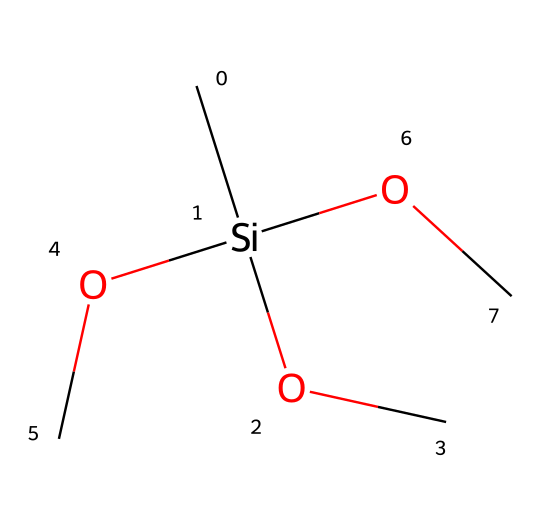What is the molecular formula of methyltrimethoxysilane? The chemical structure shows one silicon atom (Si), one carbon atom (C) from the methyl group, and three methoxy groups (-OCH3), which combine to give the molecular formula SiC4H12O3.
Answer: SiC4H12O3 How many methoxy groups are present in methyltrimethoxysilane? The chemical structure includes three -OCH3 groups attached to the silicon atom. Each methoxy group contributes to one part of the molecular structure, which is evident from the three –O and three –C in the SMILES, indicating three methoxy groups.
Answer: 3 What type of functional groups are present in this chemical? The structure reveals that there are methoxy groups (-OCH3) and a silane group (Si-R), where R represents the organic components. The presence of both methoxy and silane groups characterizes it as a silane with methoxy functionalities.
Answer: methoxy and silane groups Which atom in the structure is responsible for the silane properties? The central silicon atom (Si) is surrounded by organic groups and is key to the silane properties. The bonding of silicon with methoxy groups classifies this compound as a silane derivative.
Answer: silicon What would be the primary role of methyltrimethoxysilane in plant-based biopolymer research? Methyltrimethoxysilane can act as a coupling agent or modifier, improving the compatibility of plant-based biopolymers with inorganic materials. This is due to the reactivity of the methoxy groups, which can promote bonding with polysaccharides or proteins, facilitating composite material formation.
Answer: coupling agent What happens to the methoxy groups upon hydrolysis? When hydrolyzed, the methoxy groups (-OCH3) can transform into silanol groups (-OH), leading to the formation of a silanol network which can enhance bonding with other polymeric materials, increasing material properties such as strength and durability.
Answer: form silanol groups 